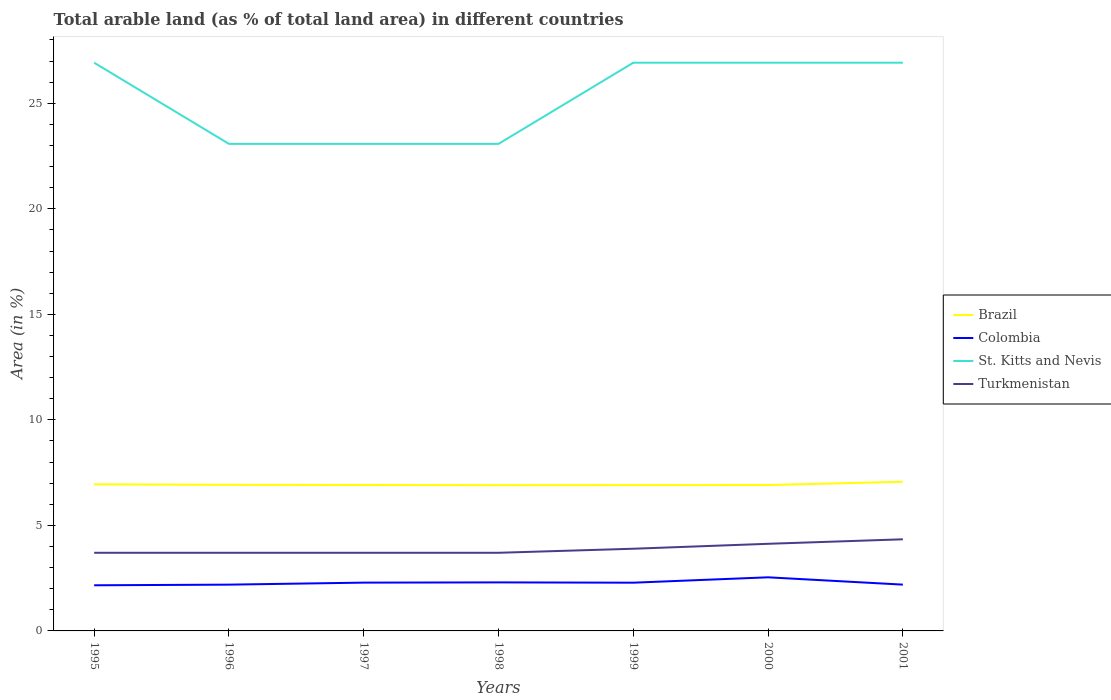Does the line corresponding to St. Kitts and Nevis intersect with the line corresponding to Colombia?
Give a very brief answer. No. Is the number of lines equal to the number of legend labels?
Provide a short and direct response. Yes. Across all years, what is the maximum percentage of arable land in Brazil?
Give a very brief answer. 6.91. In which year was the percentage of arable land in Turkmenistan maximum?
Give a very brief answer. 1995. What is the total percentage of arable land in Brazil in the graph?
Make the answer very short. 0.02. What is the difference between the highest and the second highest percentage of arable land in Colombia?
Ensure brevity in your answer.  0.38. Is the percentage of arable land in St. Kitts and Nevis strictly greater than the percentage of arable land in Turkmenistan over the years?
Offer a terse response. No. How many lines are there?
Give a very brief answer. 4. How many years are there in the graph?
Make the answer very short. 7. What is the difference between two consecutive major ticks on the Y-axis?
Your answer should be very brief. 5. Are the values on the major ticks of Y-axis written in scientific E-notation?
Your answer should be compact. No. Does the graph contain grids?
Your answer should be very brief. No. How many legend labels are there?
Make the answer very short. 4. How are the legend labels stacked?
Give a very brief answer. Vertical. What is the title of the graph?
Your response must be concise. Total arable land (as % of total land area) in different countries. Does "Myanmar" appear as one of the legend labels in the graph?
Give a very brief answer. No. What is the label or title of the X-axis?
Your answer should be very brief. Years. What is the label or title of the Y-axis?
Give a very brief answer. Area (in %). What is the Area (in %) in Brazil in 1995?
Your answer should be compact. 6.95. What is the Area (in %) of Colombia in 1995?
Your response must be concise. 2.16. What is the Area (in %) in St. Kitts and Nevis in 1995?
Provide a succinct answer. 26.92. What is the Area (in %) of Turkmenistan in 1995?
Your response must be concise. 3.7. What is the Area (in %) of Brazil in 1996?
Keep it short and to the point. 6.92. What is the Area (in %) of Colombia in 1996?
Make the answer very short. 2.19. What is the Area (in %) in St. Kitts and Nevis in 1996?
Provide a short and direct response. 23.08. What is the Area (in %) of Turkmenistan in 1996?
Your answer should be compact. 3.7. What is the Area (in %) in Brazil in 1997?
Provide a short and direct response. 6.91. What is the Area (in %) in Colombia in 1997?
Your answer should be very brief. 2.29. What is the Area (in %) of St. Kitts and Nevis in 1997?
Provide a short and direct response. 23.08. What is the Area (in %) in Turkmenistan in 1997?
Your answer should be very brief. 3.7. What is the Area (in %) of Brazil in 1998?
Provide a short and direct response. 6.91. What is the Area (in %) of Colombia in 1998?
Make the answer very short. 2.3. What is the Area (in %) in St. Kitts and Nevis in 1998?
Make the answer very short. 23.08. What is the Area (in %) of Turkmenistan in 1998?
Provide a succinct answer. 3.7. What is the Area (in %) of Brazil in 1999?
Provide a short and direct response. 6.91. What is the Area (in %) in Colombia in 1999?
Keep it short and to the point. 2.29. What is the Area (in %) of St. Kitts and Nevis in 1999?
Offer a terse response. 26.92. What is the Area (in %) of Turkmenistan in 1999?
Your answer should be compact. 3.89. What is the Area (in %) in Brazil in 2000?
Provide a succinct answer. 6.91. What is the Area (in %) in Colombia in 2000?
Keep it short and to the point. 2.54. What is the Area (in %) of St. Kitts and Nevis in 2000?
Your answer should be compact. 26.92. What is the Area (in %) of Turkmenistan in 2000?
Make the answer very short. 4.13. What is the Area (in %) in Brazil in 2001?
Provide a short and direct response. 7.07. What is the Area (in %) in Colombia in 2001?
Provide a succinct answer. 2.19. What is the Area (in %) in St. Kitts and Nevis in 2001?
Offer a very short reply. 26.92. What is the Area (in %) of Turkmenistan in 2001?
Your answer should be very brief. 4.34. Across all years, what is the maximum Area (in %) in Brazil?
Your response must be concise. 7.07. Across all years, what is the maximum Area (in %) of Colombia?
Give a very brief answer. 2.54. Across all years, what is the maximum Area (in %) in St. Kitts and Nevis?
Give a very brief answer. 26.92. Across all years, what is the maximum Area (in %) of Turkmenistan?
Make the answer very short. 4.34. Across all years, what is the minimum Area (in %) in Brazil?
Provide a succinct answer. 6.91. Across all years, what is the minimum Area (in %) in Colombia?
Give a very brief answer. 2.16. Across all years, what is the minimum Area (in %) in St. Kitts and Nevis?
Provide a short and direct response. 23.08. Across all years, what is the minimum Area (in %) in Turkmenistan?
Ensure brevity in your answer.  3.7. What is the total Area (in %) of Brazil in the graph?
Give a very brief answer. 48.58. What is the total Area (in %) of Colombia in the graph?
Offer a terse response. 15.96. What is the total Area (in %) of St. Kitts and Nevis in the graph?
Your response must be concise. 176.92. What is the total Area (in %) in Turkmenistan in the graph?
Make the answer very short. 27.17. What is the difference between the Area (in %) in Brazil in 1995 and that in 1996?
Provide a succinct answer. 0.02. What is the difference between the Area (in %) in Colombia in 1995 and that in 1996?
Provide a succinct answer. -0.03. What is the difference between the Area (in %) in St. Kitts and Nevis in 1995 and that in 1996?
Your response must be concise. 3.85. What is the difference between the Area (in %) in Turkmenistan in 1995 and that in 1996?
Your answer should be compact. 0. What is the difference between the Area (in %) of Brazil in 1995 and that in 1997?
Offer a terse response. 0.03. What is the difference between the Area (in %) of Colombia in 1995 and that in 1997?
Provide a short and direct response. -0.13. What is the difference between the Area (in %) of St. Kitts and Nevis in 1995 and that in 1997?
Provide a short and direct response. 3.85. What is the difference between the Area (in %) in Turkmenistan in 1995 and that in 1997?
Give a very brief answer. 0. What is the difference between the Area (in %) in Brazil in 1995 and that in 1998?
Your response must be concise. 0.04. What is the difference between the Area (in %) of Colombia in 1995 and that in 1998?
Your answer should be compact. -0.14. What is the difference between the Area (in %) of St. Kitts and Nevis in 1995 and that in 1998?
Make the answer very short. 3.85. What is the difference between the Area (in %) in Turkmenistan in 1995 and that in 1998?
Your answer should be compact. 0. What is the difference between the Area (in %) in Brazil in 1995 and that in 1999?
Your answer should be very brief. 0.04. What is the difference between the Area (in %) in Colombia in 1995 and that in 1999?
Offer a very short reply. -0.12. What is the difference between the Area (in %) of Turkmenistan in 1995 and that in 1999?
Provide a short and direct response. -0.19. What is the difference between the Area (in %) of Brazil in 1995 and that in 2000?
Keep it short and to the point. 0.03. What is the difference between the Area (in %) in Colombia in 1995 and that in 2000?
Offer a very short reply. -0.38. What is the difference between the Area (in %) of St. Kitts and Nevis in 1995 and that in 2000?
Ensure brevity in your answer.  0. What is the difference between the Area (in %) of Turkmenistan in 1995 and that in 2000?
Your answer should be compact. -0.43. What is the difference between the Area (in %) in Brazil in 1995 and that in 2001?
Your response must be concise. -0.12. What is the difference between the Area (in %) of Colombia in 1995 and that in 2001?
Make the answer very short. -0.03. What is the difference between the Area (in %) of St. Kitts and Nevis in 1995 and that in 2001?
Offer a very short reply. 0. What is the difference between the Area (in %) in Turkmenistan in 1995 and that in 2001?
Provide a succinct answer. -0.64. What is the difference between the Area (in %) in Brazil in 1996 and that in 1997?
Provide a short and direct response. 0.01. What is the difference between the Area (in %) of Colombia in 1996 and that in 1997?
Your answer should be compact. -0.1. What is the difference between the Area (in %) in St. Kitts and Nevis in 1996 and that in 1997?
Provide a succinct answer. 0. What is the difference between the Area (in %) of Turkmenistan in 1996 and that in 1997?
Make the answer very short. 0. What is the difference between the Area (in %) in Brazil in 1996 and that in 1998?
Ensure brevity in your answer.  0.02. What is the difference between the Area (in %) in Colombia in 1996 and that in 1998?
Your answer should be very brief. -0.11. What is the difference between the Area (in %) in St. Kitts and Nevis in 1996 and that in 1998?
Offer a very short reply. 0. What is the difference between the Area (in %) in Brazil in 1996 and that in 1999?
Make the answer very short. 0.01. What is the difference between the Area (in %) in Colombia in 1996 and that in 1999?
Your response must be concise. -0.09. What is the difference between the Area (in %) in St. Kitts and Nevis in 1996 and that in 1999?
Offer a terse response. -3.85. What is the difference between the Area (in %) of Turkmenistan in 1996 and that in 1999?
Provide a short and direct response. -0.19. What is the difference between the Area (in %) in Brazil in 1996 and that in 2000?
Offer a very short reply. 0.01. What is the difference between the Area (in %) in Colombia in 1996 and that in 2000?
Offer a terse response. -0.35. What is the difference between the Area (in %) of St. Kitts and Nevis in 1996 and that in 2000?
Keep it short and to the point. -3.85. What is the difference between the Area (in %) of Turkmenistan in 1996 and that in 2000?
Provide a short and direct response. -0.43. What is the difference between the Area (in %) of Brazil in 1996 and that in 2001?
Your answer should be very brief. -0.15. What is the difference between the Area (in %) of Colombia in 1996 and that in 2001?
Your answer should be compact. -0. What is the difference between the Area (in %) in St. Kitts and Nevis in 1996 and that in 2001?
Offer a terse response. -3.85. What is the difference between the Area (in %) in Turkmenistan in 1996 and that in 2001?
Your answer should be very brief. -0.64. What is the difference between the Area (in %) in Brazil in 1997 and that in 1998?
Your answer should be very brief. 0.01. What is the difference between the Area (in %) of Colombia in 1997 and that in 1998?
Offer a very short reply. -0.01. What is the difference between the Area (in %) of Brazil in 1997 and that in 1999?
Make the answer very short. 0. What is the difference between the Area (in %) of Colombia in 1997 and that in 1999?
Your answer should be very brief. 0. What is the difference between the Area (in %) of St. Kitts and Nevis in 1997 and that in 1999?
Keep it short and to the point. -3.85. What is the difference between the Area (in %) in Turkmenistan in 1997 and that in 1999?
Offer a terse response. -0.19. What is the difference between the Area (in %) in Brazil in 1997 and that in 2000?
Provide a succinct answer. 0. What is the difference between the Area (in %) in Colombia in 1997 and that in 2000?
Provide a succinct answer. -0.25. What is the difference between the Area (in %) in St. Kitts and Nevis in 1997 and that in 2000?
Give a very brief answer. -3.85. What is the difference between the Area (in %) in Turkmenistan in 1997 and that in 2000?
Offer a very short reply. -0.43. What is the difference between the Area (in %) in Brazil in 1997 and that in 2001?
Offer a very short reply. -0.15. What is the difference between the Area (in %) in Colombia in 1997 and that in 2001?
Your answer should be very brief. 0.09. What is the difference between the Area (in %) in St. Kitts and Nevis in 1997 and that in 2001?
Provide a succinct answer. -3.85. What is the difference between the Area (in %) of Turkmenistan in 1997 and that in 2001?
Your response must be concise. -0.64. What is the difference between the Area (in %) of Brazil in 1998 and that in 1999?
Your answer should be compact. -0. What is the difference between the Area (in %) in Colombia in 1998 and that in 1999?
Your answer should be compact. 0.01. What is the difference between the Area (in %) of St. Kitts and Nevis in 1998 and that in 1999?
Ensure brevity in your answer.  -3.85. What is the difference between the Area (in %) of Turkmenistan in 1998 and that in 1999?
Ensure brevity in your answer.  -0.19. What is the difference between the Area (in %) of Brazil in 1998 and that in 2000?
Offer a terse response. -0.01. What is the difference between the Area (in %) in Colombia in 1998 and that in 2000?
Provide a short and direct response. -0.24. What is the difference between the Area (in %) in St. Kitts and Nevis in 1998 and that in 2000?
Provide a short and direct response. -3.85. What is the difference between the Area (in %) in Turkmenistan in 1998 and that in 2000?
Your answer should be compact. -0.43. What is the difference between the Area (in %) of Brazil in 1998 and that in 2001?
Your answer should be very brief. -0.16. What is the difference between the Area (in %) of Colombia in 1998 and that in 2001?
Ensure brevity in your answer.  0.11. What is the difference between the Area (in %) of St. Kitts and Nevis in 1998 and that in 2001?
Offer a terse response. -3.85. What is the difference between the Area (in %) of Turkmenistan in 1998 and that in 2001?
Provide a short and direct response. -0.64. What is the difference between the Area (in %) of Brazil in 1999 and that in 2000?
Provide a short and direct response. -0. What is the difference between the Area (in %) of Colombia in 1999 and that in 2000?
Your answer should be very brief. -0.25. What is the difference between the Area (in %) in Turkmenistan in 1999 and that in 2000?
Provide a short and direct response. -0.23. What is the difference between the Area (in %) in Brazil in 1999 and that in 2001?
Your answer should be compact. -0.16. What is the difference between the Area (in %) in Colombia in 1999 and that in 2001?
Keep it short and to the point. 0.09. What is the difference between the Area (in %) in St. Kitts and Nevis in 1999 and that in 2001?
Keep it short and to the point. 0. What is the difference between the Area (in %) of Turkmenistan in 1999 and that in 2001?
Give a very brief answer. -0.45. What is the difference between the Area (in %) in Brazil in 2000 and that in 2001?
Your response must be concise. -0.15. What is the difference between the Area (in %) of Colombia in 2000 and that in 2001?
Make the answer very short. 0.35. What is the difference between the Area (in %) in Turkmenistan in 2000 and that in 2001?
Your answer should be very brief. -0.21. What is the difference between the Area (in %) in Brazil in 1995 and the Area (in %) in Colombia in 1996?
Your answer should be compact. 4.75. What is the difference between the Area (in %) of Brazil in 1995 and the Area (in %) of St. Kitts and Nevis in 1996?
Provide a succinct answer. -16.13. What is the difference between the Area (in %) in Brazil in 1995 and the Area (in %) in Turkmenistan in 1996?
Offer a terse response. 3.24. What is the difference between the Area (in %) in Colombia in 1995 and the Area (in %) in St. Kitts and Nevis in 1996?
Your answer should be compact. -20.91. What is the difference between the Area (in %) of Colombia in 1995 and the Area (in %) of Turkmenistan in 1996?
Provide a short and direct response. -1.54. What is the difference between the Area (in %) of St. Kitts and Nevis in 1995 and the Area (in %) of Turkmenistan in 1996?
Make the answer very short. 23.22. What is the difference between the Area (in %) in Brazil in 1995 and the Area (in %) in Colombia in 1997?
Offer a very short reply. 4.66. What is the difference between the Area (in %) of Brazil in 1995 and the Area (in %) of St. Kitts and Nevis in 1997?
Ensure brevity in your answer.  -16.13. What is the difference between the Area (in %) in Brazil in 1995 and the Area (in %) in Turkmenistan in 1997?
Your answer should be very brief. 3.24. What is the difference between the Area (in %) of Colombia in 1995 and the Area (in %) of St. Kitts and Nevis in 1997?
Offer a terse response. -20.91. What is the difference between the Area (in %) of Colombia in 1995 and the Area (in %) of Turkmenistan in 1997?
Offer a very short reply. -1.54. What is the difference between the Area (in %) in St. Kitts and Nevis in 1995 and the Area (in %) in Turkmenistan in 1997?
Your answer should be compact. 23.22. What is the difference between the Area (in %) in Brazil in 1995 and the Area (in %) in Colombia in 1998?
Give a very brief answer. 4.65. What is the difference between the Area (in %) in Brazil in 1995 and the Area (in %) in St. Kitts and Nevis in 1998?
Keep it short and to the point. -16.13. What is the difference between the Area (in %) in Brazil in 1995 and the Area (in %) in Turkmenistan in 1998?
Offer a very short reply. 3.24. What is the difference between the Area (in %) in Colombia in 1995 and the Area (in %) in St. Kitts and Nevis in 1998?
Provide a short and direct response. -20.91. What is the difference between the Area (in %) of Colombia in 1995 and the Area (in %) of Turkmenistan in 1998?
Your answer should be very brief. -1.54. What is the difference between the Area (in %) in St. Kitts and Nevis in 1995 and the Area (in %) in Turkmenistan in 1998?
Your response must be concise. 23.22. What is the difference between the Area (in %) of Brazil in 1995 and the Area (in %) of Colombia in 1999?
Keep it short and to the point. 4.66. What is the difference between the Area (in %) of Brazil in 1995 and the Area (in %) of St. Kitts and Nevis in 1999?
Your answer should be compact. -19.98. What is the difference between the Area (in %) in Brazil in 1995 and the Area (in %) in Turkmenistan in 1999?
Your response must be concise. 3.05. What is the difference between the Area (in %) of Colombia in 1995 and the Area (in %) of St. Kitts and Nevis in 1999?
Give a very brief answer. -24.76. What is the difference between the Area (in %) in Colombia in 1995 and the Area (in %) in Turkmenistan in 1999?
Provide a short and direct response. -1.73. What is the difference between the Area (in %) in St. Kitts and Nevis in 1995 and the Area (in %) in Turkmenistan in 1999?
Your answer should be compact. 23.03. What is the difference between the Area (in %) in Brazil in 1995 and the Area (in %) in Colombia in 2000?
Your response must be concise. 4.41. What is the difference between the Area (in %) in Brazil in 1995 and the Area (in %) in St. Kitts and Nevis in 2000?
Offer a terse response. -19.98. What is the difference between the Area (in %) of Brazil in 1995 and the Area (in %) of Turkmenistan in 2000?
Offer a terse response. 2.82. What is the difference between the Area (in %) in Colombia in 1995 and the Area (in %) in St. Kitts and Nevis in 2000?
Provide a short and direct response. -24.76. What is the difference between the Area (in %) in Colombia in 1995 and the Area (in %) in Turkmenistan in 2000?
Make the answer very short. -1.97. What is the difference between the Area (in %) in St. Kitts and Nevis in 1995 and the Area (in %) in Turkmenistan in 2000?
Make the answer very short. 22.79. What is the difference between the Area (in %) of Brazil in 1995 and the Area (in %) of Colombia in 2001?
Make the answer very short. 4.75. What is the difference between the Area (in %) in Brazil in 1995 and the Area (in %) in St. Kitts and Nevis in 2001?
Ensure brevity in your answer.  -19.98. What is the difference between the Area (in %) in Brazil in 1995 and the Area (in %) in Turkmenistan in 2001?
Give a very brief answer. 2.61. What is the difference between the Area (in %) of Colombia in 1995 and the Area (in %) of St. Kitts and Nevis in 2001?
Your answer should be very brief. -24.76. What is the difference between the Area (in %) of Colombia in 1995 and the Area (in %) of Turkmenistan in 2001?
Your answer should be very brief. -2.18. What is the difference between the Area (in %) in St. Kitts and Nevis in 1995 and the Area (in %) in Turkmenistan in 2001?
Give a very brief answer. 22.58. What is the difference between the Area (in %) of Brazil in 1996 and the Area (in %) of Colombia in 1997?
Keep it short and to the point. 4.63. What is the difference between the Area (in %) in Brazil in 1996 and the Area (in %) in St. Kitts and Nevis in 1997?
Keep it short and to the point. -16.15. What is the difference between the Area (in %) in Brazil in 1996 and the Area (in %) in Turkmenistan in 1997?
Make the answer very short. 3.22. What is the difference between the Area (in %) in Colombia in 1996 and the Area (in %) in St. Kitts and Nevis in 1997?
Your response must be concise. -20.88. What is the difference between the Area (in %) in Colombia in 1996 and the Area (in %) in Turkmenistan in 1997?
Make the answer very short. -1.51. What is the difference between the Area (in %) in St. Kitts and Nevis in 1996 and the Area (in %) in Turkmenistan in 1997?
Ensure brevity in your answer.  19.37. What is the difference between the Area (in %) of Brazil in 1996 and the Area (in %) of Colombia in 1998?
Give a very brief answer. 4.62. What is the difference between the Area (in %) of Brazil in 1996 and the Area (in %) of St. Kitts and Nevis in 1998?
Ensure brevity in your answer.  -16.15. What is the difference between the Area (in %) of Brazil in 1996 and the Area (in %) of Turkmenistan in 1998?
Keep it short and to the point. 3.22. What is the difference between the Area (in %) in Colombia in 1996 and the Area (in %) in St. Kitts and Nevis in 1998?
Keep it short and to the point. -20.88. What is the difference between the Area (in %) of Colombia in 1996 and the Area (in %) of Turkmenistan in 1998?
Your answer should be very brief. -1.51. What is the difference between the Area (in %) in St. Kitts and Nevis in 1996 and the Area (in %) in Turkmenistan in 1998?
Ensure brevity in your answer.  19.37. What is the difference between the Area (in %) in Brazil in 1996 and the Area (in %) in Colombia in 1999?
Your answer should be compact. 4.64. What is the difference between the Area (in %) of Brazil in 1996 and the Area (in %) of St. Kitts and Nevis in 1999?
Offer a terse response. -20. What is the difference between the Area (in %) in Brazil in 1996 and the Area (in %) in Turkmenistan in 1999?
Offer a terse response. 3.03. What is the difference between the Area (in %) of Colombia in 1996 and the Area (in %) of St. Kitts and Nevis in 1999?
Your answer should be compact. -24.73. What is the difference between the Area (in %) in Colombia in 1996 and the Area (in %) in Turkmenistan in 1999?
Your response must be concise. -1.7. What is the difference between the Area (in %) of St. Kitts and Nevis in 1996 and the Area (in %) of Turkmenistan in 1999?
Offer a very short reply. 19.18. What is the difference between the Area (in %) in Brazil in 1996 and the Area (in %) in Colombia in 2000?
Provide a succinct answer. 4.38. What is the difference between the Area (in %) of Brazil in 1996 and the Area (in %) of St. Kitts and Nevis in 2000?
Provide a succinct answer. -20. What is the difference between the Area (in %) of Brazil in 1996 and the Area (in %) of Turkmenistan in 2000?
Give a very brief answer. 2.79. What is the difference between the Area (in %) of Colombia in 1996 and the Area (in %) of St. Kitts and Nevis in 2000?
Ensure brevity in your answer.  -24.73. What is the difference between the Area (in %) in Colombia in 1996 and the Area (in %) in Turkmenistan in 2000?
Give a very brief answer. -1.94. What is the difference between the Area (in %) in St. Kitts and Nevis in 1996 and the Area (in %) in Turkmenistan in 2000?
Give a very brief answer. 18.95. What is the difference between the Area (in %) of Brazil in 1996 and the Area (in %) of Colombia in 2001?
Your answer should be very brief. 4.73. What is the difference between the Area (in %) in Brazil in 1996 and the Area (in %) in St. Kitts and Nevis in 2001?
Your answer should be compact. -20. What is the difference between the Area (in %) in Brazil in 1996 and the Area (in %) in Turkmenistan in 2001?
Provide a short and direct response. 2.58. What is the difference between the Area (in %) in Colombia in 1996 and the Area (in %) in St. Kitts and Nevis in 2001?
Make the answer very short. -24.73. What is the difference between the Area (in %) of Colombia in 1996 and the Area (in %) of Turkmenistan in 2001?
Your response must be concise. -2.15. What is the difference between the Area (in %) in St. Kitts and Nevis in 1996 and the Area (in %) in Turkmenistan in 2001?
Your answer should be compact. 18.74. What is the difference between the Area (in %) of Brazil in 1997 and the Area (in %) of Colombia in 1998?
Provide a short and direct response. 4.61. What is the difference between the Area (in %) in Brazil in 1997 and the Area (in %) in St. Kitts and Nevis in 1998?
Ensure brevity in your answer.  -16.16. What is the difference between the Area (in %) of Brazil in 1997 and the Area (in %) of Turkmenistan in 1998?
Ensure brevity in your answer.  3.21. What is the difference between the Area (in %) in Colombia in 1997 and the Area (in %) in St. Kitts and Nevis in 1998?
Give a very brief answer. -20.79. What is the difference between the Area (in %) of Colombia in 1997 and the Area (in %) of Turkmenistan in 1998?
Offer a very short reply. -1.41. What is the difference between the Area (in %) of St. Kitts and Nevis in 1997 and the Area (in %) of Turkmenistan in 1998?
Make the answer very short. 19.37. What is the difference between the Area (in %) in Brazil in 1997 and the Area (in %) in Colombia in 1999?
Ensure brevity in your answer.  4.63. What is the difference between the Area (in %) in Brazil in 1997 and the Area (in %) in St. Kitts and Nevis in 1999?
Your answer should be very brief. -20.01. What is the difference between the Area (in %) of Brazil in 1997 and the Area (in %) of Turkmenistan in 1999?
Keep it short and to the point. 3.02. What is the difference between the Area (in %) in Colombia in 1997 and the Area (in %) in St. Kitts and Nevis in 1999?
Offer a terse response. -24.63. What is the difference between the Area (in %) in Colombia in 1997 and the Area (in %) in Turkmenistan in 1999?
Provide a short and direct response. -1.61. What is the difference between the Area (in %) in St. Kitts and Nevis in 1997 and the Area (in %) in Turkmenistan in 1999?
Ensure brevity in your answer.  19.18. What is the difference between the Area (in %) in Brazil in 1997 and the Area (in %) in Colombia in 2000?
Provide a short and direct response. 4.37. What is the difference between the Area (in %) in Brazil in 1997 and the Area (in %) in St. Kitts and Nevis in 2000?
Ensure brevity in your answer.  -20.01. What is the difference between the Area (in %) in Brazil in 1997 and the Area (in %) in Turkmenistan in 2000?
Your answer should be very brief. 2.79. What is the difference between the Area (in %) of Colombia in 1997 and the Area (in %) of St. Kitts and Nevis in 2000?
Your answer should be compact. -24.63. What is the difference between the Area (in %) of Colombia in 1997 and the Area (in %) of Turkmenistan in 2000?
Offer a terse response. -1.84. What is the difference between the Area (in %) of St. Kitts and Nevis in 1997 and the Area (in %) of Turkmenistan in 2000?
Your answer should be very brief. 18.95. What is the difference between the Area (in %) in Brazil in 1997 and the Area (in %) in Colombia in 2001?
Make the answer very short. 4.72. What is the difference between the Area (in %) of Brazil in 1997 and the Area (in %) of St. Kitts and Nevis in 2001?
Your answer should be compact. -20.01. What is the difference between the Area (in %) in Brazil in 1997 and the Area (in %) in Turkmenistan in 2001?
Your answer should be very brief. 2.57. What is the difference between the Area (in %) of Colombia in 1997 and the Area (in %) of St. Kitts and Nevis in 2001?
Offer a terse response. -24.63. What is the difference between the Area (in %) in Colombia in 1997 and the Area (in %) in Turkmenistan in 2001?
Provide a succinct answer. -2.05. What is the difference between the Area (in %) in St. Kitts and Nevis in 1997 and the Area (in %) in Turkmenistan in 2001?
Your answer should be compact. 18.74. What is the difference between the Area (in %) of Brazil in 1998 and the Area (in %) of Colombia in 1999?
Provide a short and direct response. 4.62. What is the difference between the Area (in %) of Brazil in 1998 and the Area (in %) of St. Kitts and Nevis in 1999?
Make the answer very short. -20.02. What is the difference between the Area (in %) in Brazil in 1998 and the Area (in %) in Turkmenistan in 1999?
Your response must be concise. 3.01. What is the difference between the Area (in %) of Colombia in 1998 and the Area (in %) of St. Kitts and Nevis in 1999?
Give a very brief answer. -24.62. What is the difference between the Area (in %) of Colombia in 1998 and the Area (in %) of Turkmenistan in 1999?
Ensure brevity in your answer.  -1.59. What is the difference between the Area (in %) in St. Kitts and Nevis in 1998 and the Area (in %) in Turkmenistan in 1999?
Give a very brief answer. 19.18. What is the difference between the Area (in %) in Brazil in 1998 and the Area (in %) in Colombia in 2000?
Make the answer very short. 4.37. What is the difference between the Area (in %) of Brazil in 1998 and the Area (in %) of St. Kitts and Nevis in 2000?
Your answer should be compact. -20.02. What is the difference between the Area (in %) of Brazil in 1998 and the Area (in %) of Turkmenistan in 2000?
Your response must be concise. 2.78. What is the difference between the Area (in %) in Colombia in 1998 and the Area (in %) in St. Kitts and Nevis in 2000?
Your response must be concise. -24.62. What is the difference between the Area (in %) of Colombia in 1998 and the Area (in %) of Turkmenistan in 2000?
Offer a terse response. -1.83. What is the difference between the Area (in %) of St. Kitts and Nevis in 1998 and the Area (in %) of Turkmenistan in 2000?
Your answer should be very brief. 18.95. What is the difference between the Area (in %) of Brazil in 1998 and the Area (in %) of Colombia in 2001?
Your answer should be very brief. 4.71. What is the difference between the Area (in %) of Brazil in 1998 and the Area (in %) of St. Kitts and Nevis in 2001?
Make the answer very short. -20.02. What is the difference between the Area (in %) in Brazil in 1998 and the Area (in %) in Turkmenistan in 2001?
Offer a terse response. 2.56. What is the difference between the Area (in %) in Colombia in 1998 and the Area (in %) in St. Kitts and Nevis in 2001?
Your response must be concise. -24.62. What is the difference between the Area (in %) of Colombia in 1998 and the Area (in %) of Turkmenistan in 2001?
Your answer should be compact. -2.04. What is the difference between the Area (in %) in St. Kitts and Nevis in 1998 and the Area (in %) in Turkmenistan in 2001?
Ensure brevity in your answer.  18.74. What is the difference between the Area (in %) of Brazil in 1999 and the Area (in %) of Colombia in 2000?
Offer a terse response. 4.37. What is the difference between the Area (in %) in Brazil in 1999 and the Area (in %) in St. Kitts and Nevis in 2000?
Provide a succinct answer. -20.01. What is the difference between the Area (in %) of Brazil in 1999 and the Area (in %) of Turkmenistan in 2000?
Your response must be concise. 2.78. What is the difference between the Area (in %) in Colombia in 1999 and the Area (in %) in St. Kitts and Nevis in 2000?
Offer a terse response. -24.64. What is the difference between the Area (in %) of Colombia in 1999 and the Area (in %) of Turkmenistan in 2000?
Your answer should be very brief. -1.84. What is the difference between the Area (in %) of St. Kitts and Nevis in 1999 and the Area (in %) of Turkmenistan in 2000?
Ensure brevity in your answer.  22.79. What is the difference between the Area (in %) in Brazil in 1999 and the Area (in %) in Colombia in 2001?
Give a very brief answer. 4.72. What is the difference between the Area (in %) in Brazil in 1999 and the Area (in %) in St. Kitts and Nevis in 2001?
Provide a short and direct response. -20.01. What is the difference between the Area (in %) of Brazil in 1999 and the Area (in %) of Turkmenistan in 2001?
Make the answer very short. 2.57. What is the difference between the Area (in %) of Colombia in 1999 and the Area (in %) of St. Kitts and Nevis in 2001?
Your answer should be compact. -24.64. What is the difference between the Area (in %) in Colombia in 1999 and the Area (in %) in Turkmenistan in 2001?
Your response must be concise. -2.06. What is the difference between the Area (in %) of St. Kitts and Nevis in 1999 and the Area (in %) of Turkmenistan in 2001?
Your response must be concise. 22.58. What is the difference between the Area (in %) of Brazil in 2000 and the Area (in %) of Colombia in 2001?
Offer a terse response. 4.72. What is the difference between the Area (in %) of Brazil in 2000 and the Area (in %) of St. Kitts and Nevis in 2001?
Your answer should be compact. -20.01. What is the difference between the Area (in %) in Brazil in 2000 and the Area (in %) in Turkmenistan in 2001?
Your response must be concise. 2.57. What is the difference between the Area (in %) in Colombia in 2000 and the Area (in %) in St. Kitts and Nevis in 2001?
Keep it short and to the point. -24.38. What is the difference between the Area (in %) of Colombia in 2000 and the Area (in %) of Turkmenistan in 2001?
Offer a terse response. -1.8. What is the difference between the Area (in %) of St. Kitts and Nevis in 2000 and the Area (in %) of Turkmenistan in 2001?
Provide a short and direct response. 22.58. What is the average Area (in %) in Brazil per year?
Offer a terse response. 6.94. What is the average Area (in %) in Colombia per year?
Offer a very short reply. 2.28. What is the average Area (in %) of St. Kitts and Nevis per year?
Ensure brevity in your answer.  25.27. What is the average Area (in %) in Turkmenistan per year?
Offer a very short reply. 3.88. In the year 1995, what is the difference between the Area (in %) of Brazil and Area (in %) of Colombia?
Make the answer very short. 4.78. In the year 1995, what is the difference between the Area (in %) of Brazil and Area (in %) of St. Kitts and Nevis?
Ensure brevity in your answer.  -19.98. In the year 1995, what is the difference between the Area (in %) in Brazil and Area (in %) in Turkmenistan?
Offer a very short reply. 3.24. In the year 1995, what is the difference between the Area (in %) in Colombia and Area (in %) in St. Kitts and Nevis?
Provide a short and direct response. -24.76. In the year 1995, what is the difference between the Area (in %) in Colombia and Area (in %) in Turkmenistan?
Your answer should be very brief. -1.54. In the year 1995, what is the difference between the Area (in %) of St. Kitts and Nevis and Area (in %) of Turkmenistan?
Make the answer very short. 23.22. In the year 1996, what is the difference between the Area (in %) in Brazil and Area (in %) in Colombia?
Ensure brevity in your answer.  4.73. In the year 1996, what is the difference between the Area (in %) in Brazil and Area (in %) in St. Kitts and Nevis?
Your response must be concise. -16.15. In the year 1996, what is the difference between the Area (in %) of Brazil and Area (in %) of Turkmenistan?
Your response must be concise. 3.22. In the year 1996, what is the difference between the Area (in %) of Colombia and Area (in %) of St. Kitts and Nevis?
Offer a very short reply. -20.88. In the year 1996, what is the difference between the Area (in %) of Colombia and Area (in %) of Turkmenistan?
Your answer should be very brief. -1.51. In the year 1996, what is the difference between the Area (in %) in St. Kitts and Nevis and Area (in %) in Turkmenistan?
Give a very brief answer. 19.37. In the year 1997, what is the difference between the Area (in %) in Brazil and Area (in %) in Colombia?
Offer a terse response. 4.63. In the year 1997, what is the difference between the Area (in %) in Brazil and Area (in %) in St. Kitts and Nevis?
Provide a succinct answer. -16.16. In the year 1997, what is the difference between the Area (in %) in Brazil and Area (in %) in Turkmenistan?
Your response must be concise. 3.21. In the year 1997, what is the difference between the Area (in %) of Colombia and Area (in %) of St. Kitts and Nevis?
Offer a very short reply. -20.79. In the year 1997, what is the difference between the Area (in %) in Colombia and Area (in %) in Turkmenistan?
Offer a very short reply. -1.41. In the year 1997, what is the difference between the Area (in %) in St. Kitts and Nevis and Area (in %) in Turkmenistan?
Your answer should be very brief. 19.37. In the year 1998, what is the difference between the Area (in %) in Brazil and Area (in %) in Colombia?
Your answer should be very brief. 4.61. In the year 1998, what is the difference between the Area (in %) of Brazil and Area (in %) of St. Kitts and Nevis?
Provide a short and direct response. -16.17. In the year 1998, what is the difference between the Area (in %) in Brazil and Area (in %) in Turkmenistan?
Keep it short and to the point. 3.2. In the year 1998, what is the difference between the Area (in %) in Colombia and Area (in %) in St. Kitts and Nevis?
Give a very brief answer. -20.78. In the year 1998, what is the difference between the Area (in %) in Colombia and Area (in %) in Turkmenistan?
Provide a succinct answer. -1.4. In the year 1998, what is the difference between the Area (in %) of St. Kitts and Nevis and Area (in %) of Turkmenistan?
Make the answer very short. 19.37. In the year 1999, what is the difference between the Area (in %) in Brazil and Area (in %) in Colombia?
Give a very brief answer. 4.62. In the year 1999, what is the difference between the Area (in %) in Brazil and Area (in %) in St. Kitts and Nevis?
Keep it short and to the point. -20.01. In the year 1999, what is the difference between the Area (in %) of Brazil and Area (in %) of Turkmenistan?
Your response must be concise. 3.01. In the year 1999, what is the difference between the Area (in %) of Colombia and Area (in %) of St. Kitts and Nevis?
Give a very brief answer. -24.64. In the year 1999, what is the difference between the Area (in %) of Colombia and Area (in %) of Turkmenistan?
Make the answer very short. -1.61. In the year 1999, what is the difference between the Area (in %) in St. Kitts and Nevis and Area (in %) in Turkmenistan?
Your answer should be very brief. 23.03. In the year 2000, what is the difference between the Area (in %) in Brazil and Area (in %) in Colombia?
Make the answer very short. 4.37. In the year 2000, what is the difference between the Area (in %) in Brazil and Area (in %) in St. Kitts and Nevis?
Your response must be concise. -20.01. In the year 2000, what is the difference between the Area (in %) of Brazil and Area (in %) of Turkmenistan?
Your answer should be compact. 2.78. In the year 2000, what is the difference between the Area (in %) in Colombia and Area (in %) in St. Kitts and Nevis?
Your answer should be compact. -24.38. In the year 2000, what is the difference between the Area (in %) in Colombia and Area (in %) in Turkmenistan?
Your answer should be compact. -1.59. In the year 2000, what is the difference between the Area (in %) in St. Kitts and Nevis and Area (in %) in Turkmenistan?
Provide a short and direct response. 22.79. In the year 2001, what is the difference between the Area (in %) in Brazil and Area (in %) in Colombia?
Your answer should be compact. 4.87. In the year 2001, what is the difference between the Area (in %) of Brazil and Area (in %) of St. Kitts and Nevis?
Your response must be concise. -19.86. In the year 2001, what is the difference between the Area (in %) of Brazil and Area (in %) of Turkmenistan?
Your response must be concise. 2.73. In the year 2001, what is the difference between the Area (in %) of Colombia and Area (in %) of St. Kitts and Nevis?
Keep it short and to the point. -24.73. In the year 2001, what is the difference between the Area (in %) of Colombia and Area (in %) of Turkmenistan?
Provide a short and direct response. -2.15. In the year 2001, what is the difference between the Area (in %) in St. Kitts and Nevis and Area (in %) in Turkmenistan?
Offer a terse response. 22.58. What is the ratio of the Area (in %) in Brazil in 1995 to that in 1996?
Give a very brief answer. 1. What is the ratio of the Area (in %) in Brazil in 1995 to that in 1997?
Provide a succinct answer. 1. What is the ratio of the Area (in %) of Colombia in 1995 to that in 1997?
Your response must be concise. 0.94. What is the ratio of the Area (in %) in Turkmenistan in 1995 to that in 1997?
Offer a very short reply. 1. What is the ratio of the Area (in %) in Brazil in 1995 to that in 1998?
Ensure brevity in your answer.  1.01. What is the ratio of the Area (in %) of Colombia in 1995 to that in 1998?
Offer a terse response. 0.94. What is the ratio of the Area (in %) in St. Kitts and Nevis in 1995 to that in 1998?
Your answer should be very brief. 1.17. What is the ratio of the Area (in %) of Turkmenistan in 1995 to that in 1998?
Your answer should be very brief. 1. What is the ratio of the Area (in %) in Brazil in 1995 to that in 1999?
Make the answer very short. 1.01. What is the ratio of the Area (in %) of Colombia in 1995 to that in 1999?
Your answer should be very brief. 0.95. What is the ratio of the Area (in %) in St. Kitts and Nevis in 1995 to that in 1999?
Make the answer very short. 1. What is the ratio of the Area (in %) in Turkmenistan in 1995 to that in 1999?
Provide a short and direct response. 0.95. What is the ratio of the Area (in %) of Brazil in 1995 to that in 2000?
Keep it short and to the point. 1. What is the ratio of the Area (in %) in Colombia in 1995 to that in 2000?
Keep it short and to the point. 0.85. What is the ratio of the Area (in %) in St. Kitts and Nevis in 1995 to that in 2000?
Keep it short and to the point. 1. What is the ratio of the Area (in %) of Turkmenistan in 1995 to that in 2000?
Offer a terse response. 0.9. What is the ratio of the Area (in %) of Brazil in 1995 to that in 2001?
Your response must be concise. 0.98. What is the ratio of the Area (in %) of Colombia in 1995 to that in 2001?
Your answer should be very brief. 0.99. What is the ratio of the Area (in %) of St. Kitts and Nevis in 1995 to that in 2001?
Offer a terse response. 1. What is the ratio of the Area (in %) of Turkmenistan in 1995 to that in 2001?
Your response must be concise. 0.85. What is the ratio of the Area (in %) of Brazil in 1996 to that in 1997?
Your response must be concise. 1. What is the ratio of the Area (in %) in St. Kitts and Nevis in 1996 to that in 1997?
Your answer should be compact. 1. What is the ratio of the Area (in %) of Turkmenistan in 1996 to that in 1997?
Make the answer very short. 1. What is the ratio of the Area (in %) in Colombia in 1996 to that in 1998?
Offer a very short reply. 0.95. What is the ratio of the Area (in %) in St. Kitts and Nevis in 1996 to that in 1998?
Give a very brief answer. 1. What is the ratio of the Area (in %) in Turkmenistan in 1996 to that in 1998?
Offer a terse response. 1. What is the ratio of the Area (in %) of Colombia in 1996 to that in 1999?
Ensure brevity in your answer.  0.96. What is the ratio of the Area (in %) of Turkmenistan in 1996 to that in 1999?
Provide a short and direct response. 0.95. What is the ratio of the Area (in %) in Colombia in 1996 to that in 2000?
Provide a succinct answer. 0.86. What is the ratio of the Area (in %) in Turkmenistan in 1996 to that in 2000?
Keep it short and to the point. 0.9. What is the ratio of the Area (in %) of Brazil in 1996 to that in 2001?
Make the answer very short. 0.98. What is the ratio of the Area (in %) in Colombia in 1996 to that in 2001?
Ensure brevity in your answer.  1. What is the ratio of the Area (in %) in Turkmenistan in 1996 to that in 2001?
Offer a very short reply. 0.85. What is the ratio of the Area (in %) of Colombia in 1997 to that in 1998?
Your answer should be very brief. 1. What is the ratio of the Area (in %) in St. Kitts and Nevis in 1997 to that in 1998?
Keep it short and to the point. 1. What is the ratio of the Area (in %) in Brazil in 1997 to that in 1999?
Your answer should be compact. 1. What is the ratio of the Area (in %) of Colombia in 1997 to that in 1999?
Make the answer very short. 1. What is the ratio of the Area (in %) in St. Kitts and Nevis in 1997 to that in 1999?
Your response must be concise. 0.86. What is the ratio of the Area (in %) of Turkmenistan in 1997 to that in 1999?
Offer a terse response. 0.95. What is the ratio of the Area (in %) of Brazil in 1997 to that in 2000?
Offer a very short reply. 1. What is the ratio of the Area (in %) in Colombia in 1997 to that in 2000?
Give a very brief answer. 0.9. What is the ratio of the Area (in %) in Turkmenistan in 1997 to that in 2000?
Make the answer very short. 0.9. What is the ratio of the Area (in %) of Brazil in 1997 to that in 2001?
Your answer should be very brief. 0.98. What is the ratio of the Area (in %) of Colombia in 1997 to that in 2001?
Offer a very short reply. 1.04. What is the ratio of the Area (in %) in Turkmenistan in 1997 to that in 2001?
Keep it short and to the point. 0.85. What is the ratio of the Area (in %) in Brazil in 1998 to that in 1999?
Keep it short and to the point. 1. What is the ratio of the Area (in %) in Colombia in 1998 to that in 1999?
Offer a terse response. 1.01. What is the ratio of the Area (in %) in St. Kitts and Nevis in 1998 to that in 1999?
Offer a very short reply. 0.86. What is the ratio of the Area (in %) of Turkmenistan in 1998 to that in 1999?
Make the answer very short. 0.95. What is the ratio of the Area (in %) of Brazil in 1998 to that in 2000?
Make the answer very short. 1. What is the ratio of the Area (in %) in Colombia in 1998 to that in 2000?
Your response must be concise. 0.91. What is the ratio of the Area (in %) in St. Kitts and Nevis in 1998 to that in 2000?
Provide a short and direct response. 0.86. What is the ratio of the Area (in %) in Turkmenistan in 1998 to that in 2000?
Make the answer very short. 0.9. What is the ratio of the Area (in %) of Brazil in 1998 to that in 2001?
Give a very brief answer. 0.98. What is the ratio of the Area (in %) in Colombia in 1998 to that in 2001?
Offer a very short reply. 1.05. What is the ratio of the Area (in %) in St. Kitts and Nevis in 1998 to that in 2001?
Your response must be concise. 0.86. What is the ratio of the Area (in %) in Turkmenistan in 1998 to that in 2001?
Ensure brevity in your answer.  0.85. What is the ratio of the Area (in %) in Colombia in 1999 to that in 2000?
Give a very brief answer. 0.9. What is the ratio of the Area (in %) in Turkmenistan in 1999 to that in 2000?
Offer a terse response. 0.94. What is the ratio of the Area (in %) of Brazil in 1999 to that in 2001?
Make the answer very short. 0.98. What is the ratio of the Area (in %) of Colombia in 1999 to that in 2001?
Ensure brevity in your answer.  1.04. What is the ratio of the Area (in %) of Turkmenistan in 1999 to that in 2001?
Make the answer very short. 0.9. What is the ratio of the Area (in %) in Brazil in 2000 to that in 2001?
Offer a very short reply. 0.98. What is the ratio of the Area (in %) of Colombia in 2000 to that in 2001?
Your response must be concise. 1.16. What is the ratio of the Area (in %) of St. Kitts and Nevis in 2000 to that in 2001?
Offer a terse response. 1. What is the ratio of the Area (in %) of Turkmenistan in 2000 to that in 2001?
Provide a short and direct response. 0.95. What is the difference between the highest and the second highest Area (in %) of Brazil?
Keep it short and to the point. 0.12. What is the difference between the highest and the second highest Area (in %) in Colombia?
Keep it short and to the point. 0.24. What is the difference between the highest and the second highest Area (in %) in St. Kitts and Nevis?
Provide a short and direct response. 0. What is the difference between the highest and the second highest Area (in %) in Turkmenistan?
Offer a terse response. 0.21. What is the difference between the highest and the lowest Area (in %) of Brazil?
Give a very brief answer. 0.16. What is the difference between the highest and the lowest Area (in %) of Colombia?
Give a very brief answer. 0.38. What is the difference between the highest and the lowest Area (in %) in St. Kitts and Nevis?
Make the answer very short. 3.85. What is the difference between the highest and the lowest Area (in %) of Turkmenistan?
Keep it short and to the point. 0.64. 